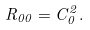<formula> <loc_0><loc_0><loc_500><loc_500>R _ { 0 0 } = C _ { 0 } ^ { 2 } .</formula> 